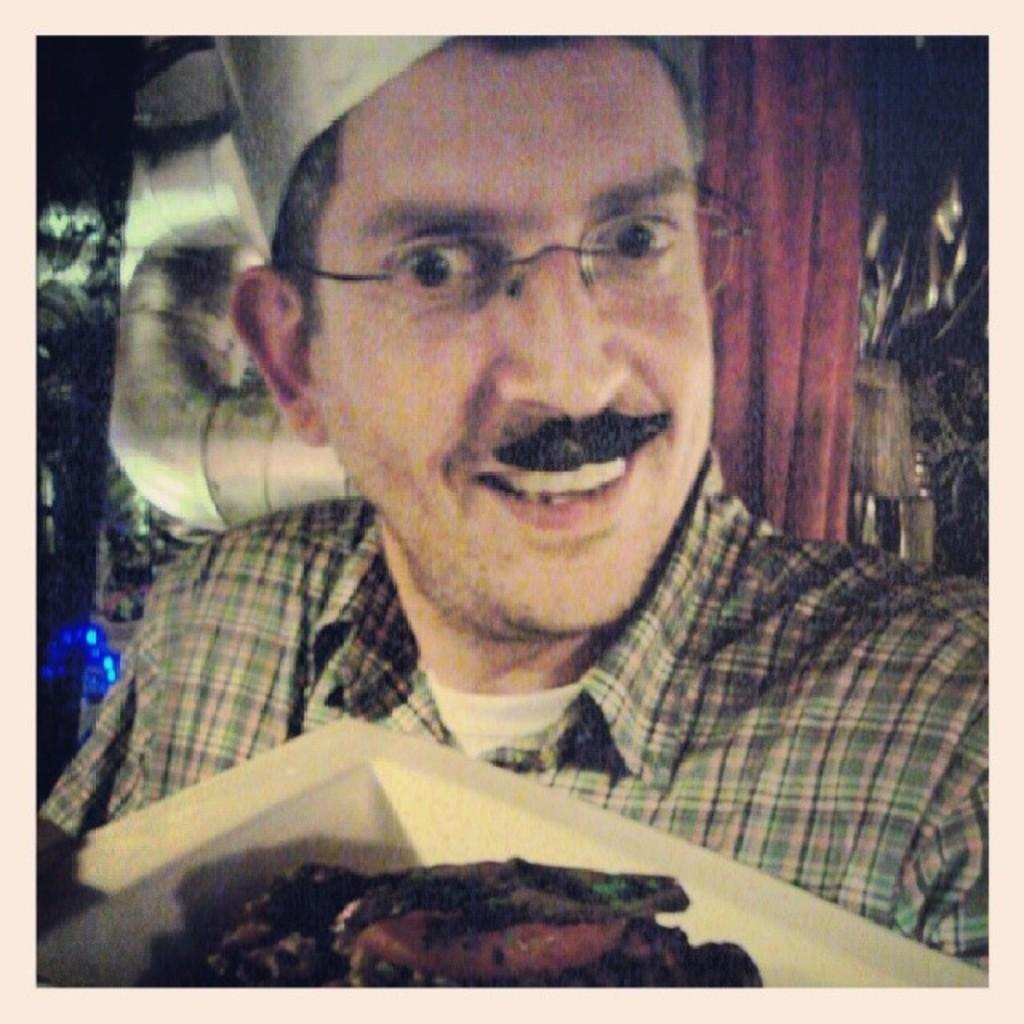Who or what is present in the image? There is a person in the image. What is the person holding in the image? The person is holding a plate. What is on the plate that the person is holding? There is food on the plate. What can be seen behind the person in the image? There is a wall visible behind the person. How does the person's breath affect the food on the plate in the image? The person's breath does not affect the food on the plate in the image, as there is no indication of the person exhaling or interacting with the food in any way. 